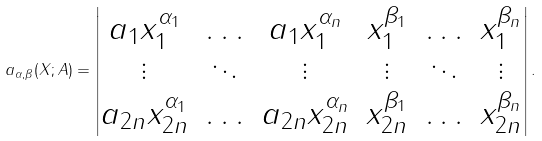<formula> <loc_0><loc_0><loc_500><loc_500>a _ { \alpha , \beta } ( X ; A ) = \begin{vmatrix} a _ { 1 } x _ { 1 } ^ { \alpha _ { 1 } } & \hdots & a _ { 1 } x _ { 1 } ^ { \alpha _ { n } } & x _ { 1 } ^ { \beta _ { 1 } } & \hdots & x _ { 1 } ^ { \beta _ { n } } \\ \vdots & \ddots & \vdots & \vdots & \ddots & \vdots \\ a _ { 2 n } x _ { 2 n } ^ { \alpha _ { 1 } } & \hdots & a _ { 2 n } x _ { 2 n } ^ { \alpha _ { n } } & x _ { 2 n } ^ { \beta _ { 1 } } & \hdots & x _ { 2 n } ^ { \beta _ { n } } \\ \end{vmatrix} .</formula> 